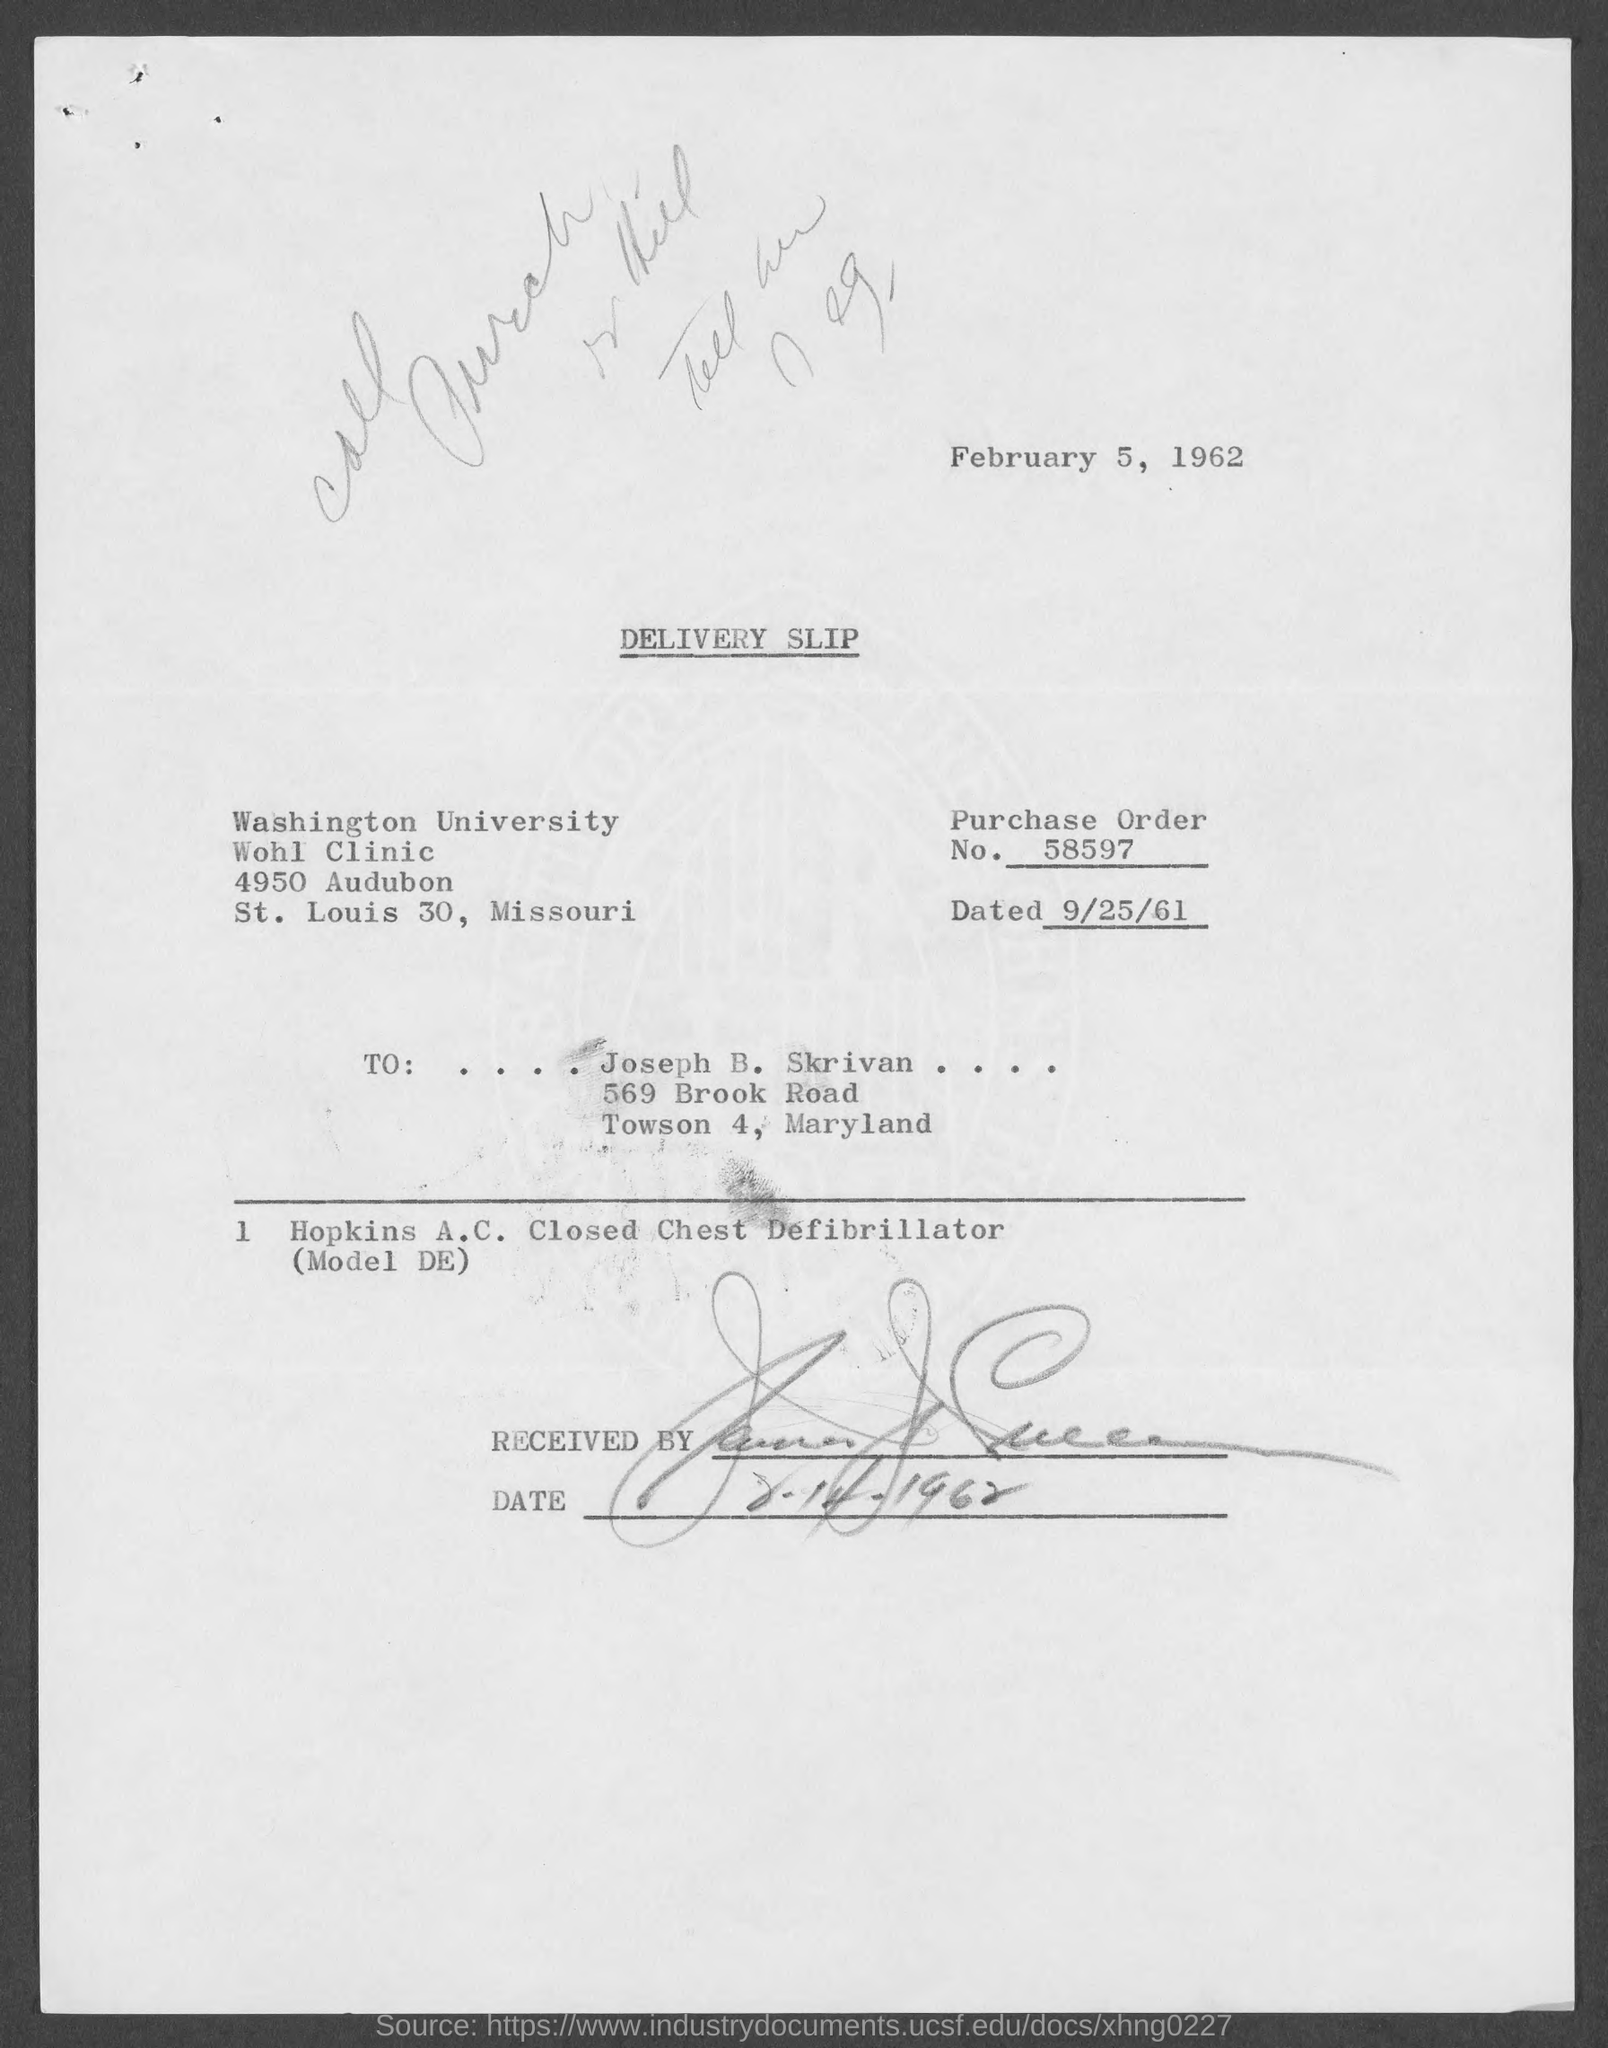Indicate a few pertinent items in this graphic. The person to whom the letter was sent is Joseph B. Skrivan. The name of the university mentioned in the given form is Washington University. The given page mentions a purchase order number of 58597. The order dated September 25, 1961, is mentioned on the slip provided. 